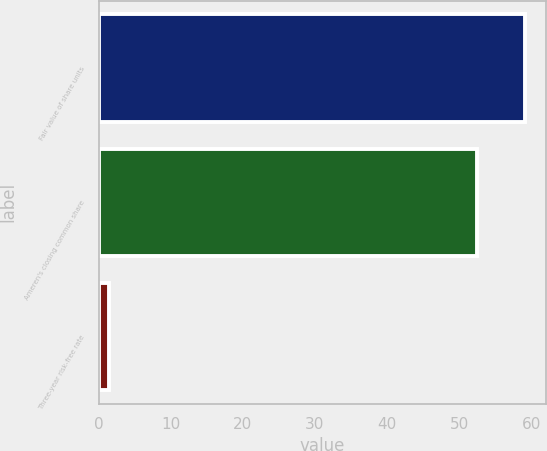<chart> <loc_0><loc_0><loc_500><loc_500><bar_chart><fcel>Fair value of share units<fcel>Ameren's closing common share<fcel>Three-year risk-free rate<nl><fcel>59.16<fcel>52.46<fcel>1.47<nl></chart> 